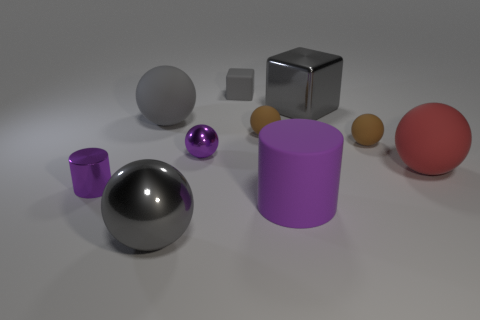Can you explain the lighting in this scene? The lighting in this scene seems to be diffused, possibly from an overhead source, resulting in soft shadows beneath the objects. This type of lighting helps to reduce harsh contrasts and bring out the colors and textures of the objects, highlighting their shapes and giving a balanced, three-dimensional feel to the image.  Does the lighting suggest anything about the setting? The even and controlled lighting, along with the lack of any natural light indicators such as sunlight or sky, suggests this is a staged scene, likely within a studio setting. The lighting is designed to minimize distraction and make the objects the sole focus of the composition. 